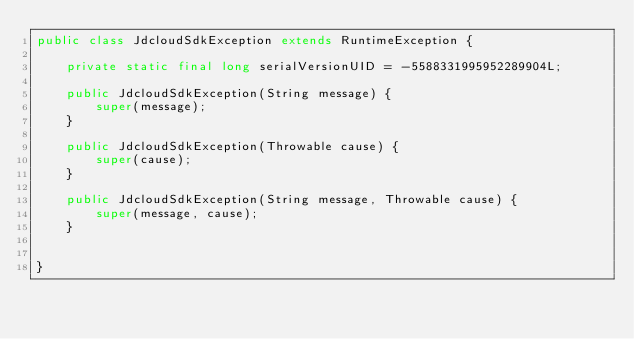<code> <loc_0><loc_0><loc_500><loc_500><_Java_>public class JdcloudSdkException extends RuntimeException {

	private static final long serialVersionUID = -5588331995952289904L;

	public JdcloudSdkException(String message) {
		super(message);
	}

	public JdcloudSdkException(Throwable cause) {
		super(cause);
	}

	public JdcloudSdkException(String message, Throwable cause) {
		super(message, cause);
	}
	

}
</code> 